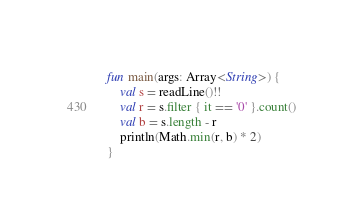<code> <loc_0><loc_0><loc_500><loc_500><_Kotlin_>fun main(args: Array<String>) {
    val s = readLine()!!
    val r = s.filter { it == '0' }.count()
    val b = s.length - r
    println(Math.min(r, b) * 2)
}
</code> 